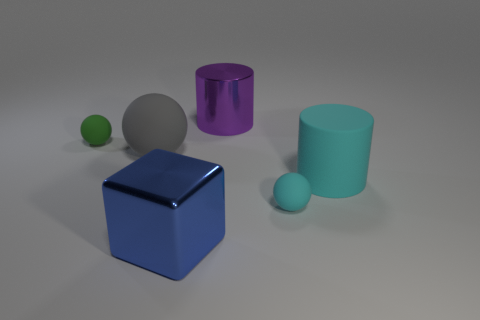Add 2 cyan rubber spheres. How many objects exist? 8 Subtract all small balls. How many balls are left? 1 Subtract all blocks. How many objects are left? 5 Subtract 1 balls. How many balls are left? 2 Subtract all cyan cylinders. How many cylinders are left? 1 Subtract all purple cylinders. Subtract all green blocks. How many cylinders are left? 1 Subtract all green cylinders. How many purple cubes are left? 0 Subtract all gray shiny spheres. Subtract all tiny rubber things. How many objects are left? 4 Add 6 green rubber spheres. How many green rubber spheres are left? 7 Add 4 large cubes. How many large cubes exist? 5 